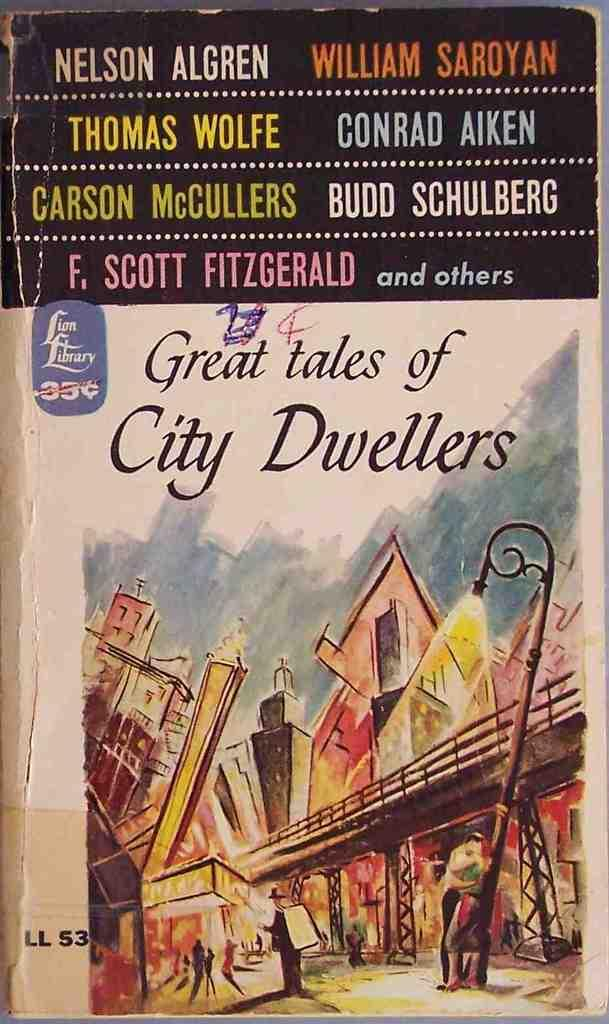<image>
Offer a succinct explanation of the picture presented. A "Great tales of City Dwellers" book appears to be quite old and worn. 